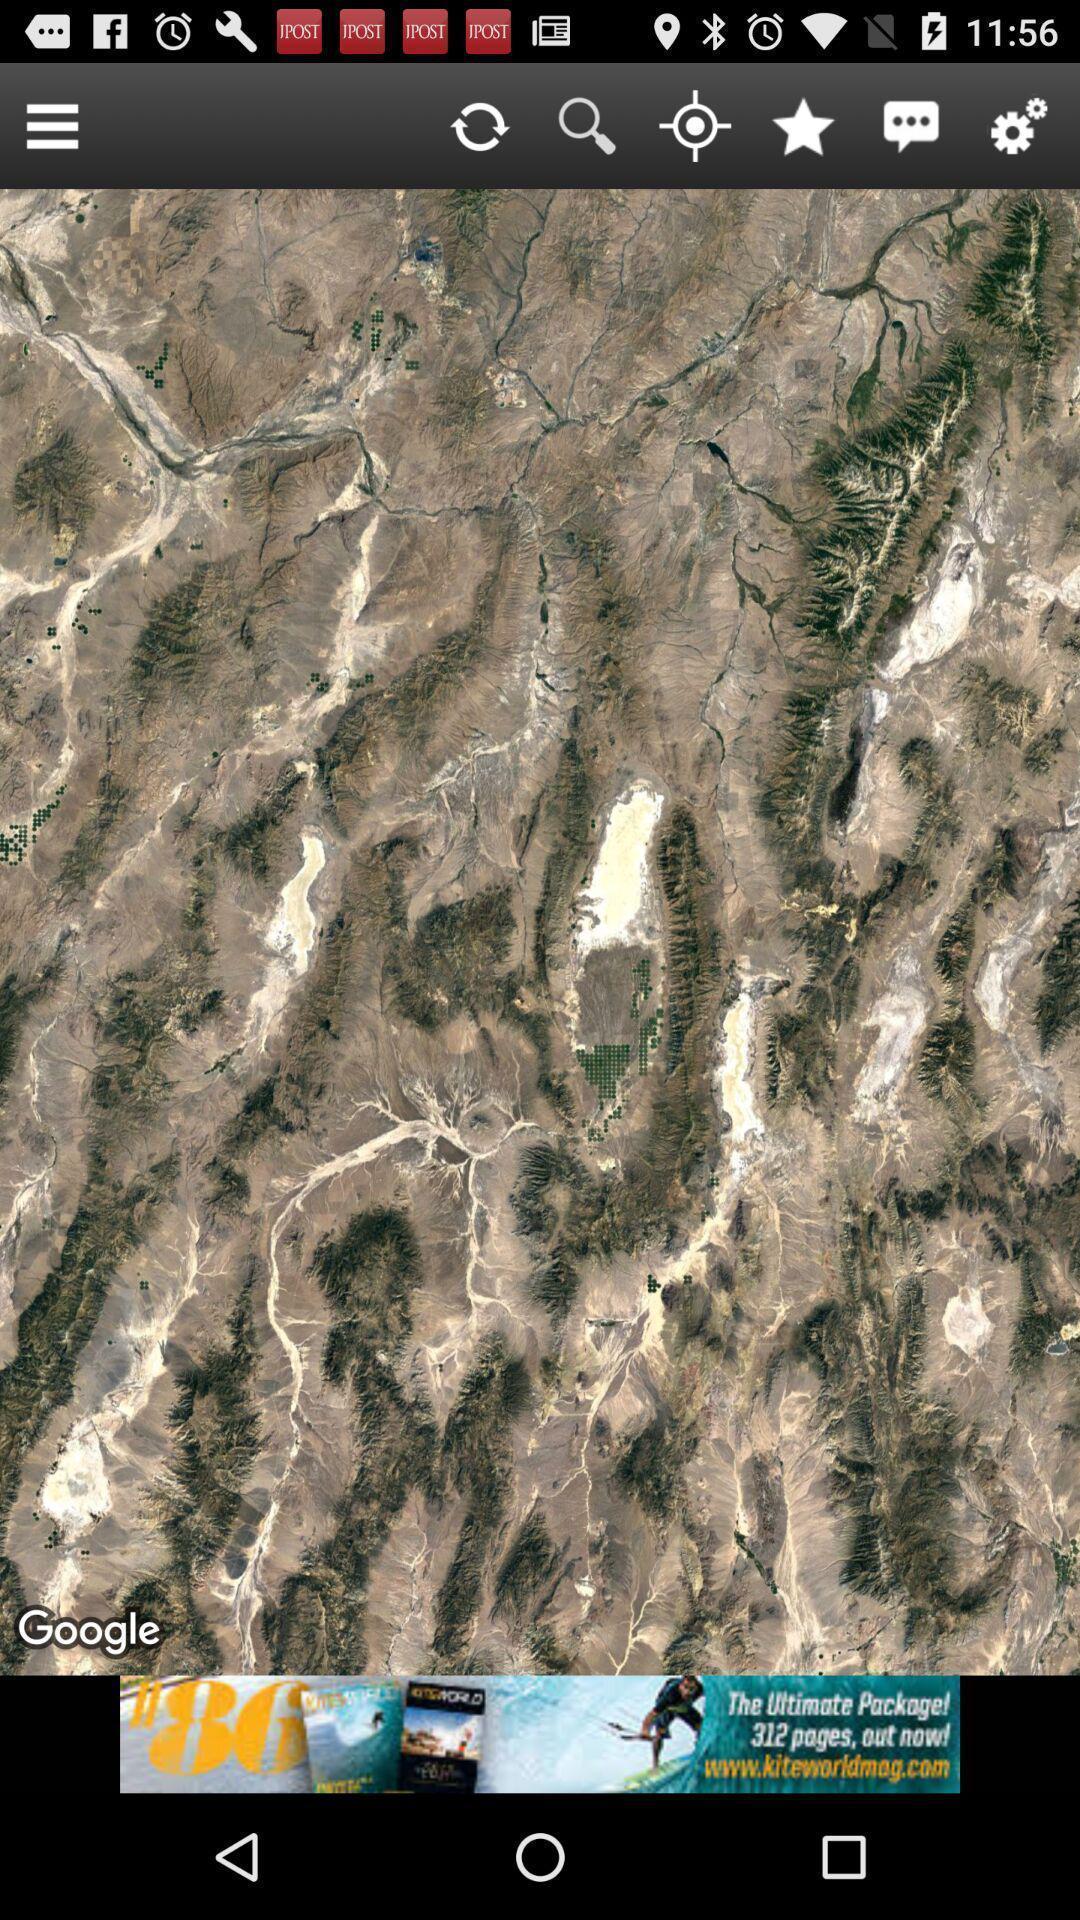Please provide a description for this image. Page displaying image with multiple icons. 